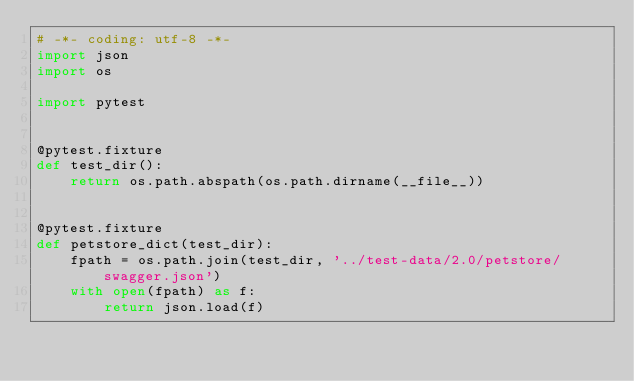Convert code to text. <code><loc_0><loc_0><loc_500><loc_500><_Python_># -*- coding: utf-8 -*-
import json
import os

import pytest


@pytest.fixture
def test_dir():
    return os.path.abspath(os.path.dirname(__file__))


@pytest.fixture
def petstore_dict(test_dir):
    fpath = os.path.join(test_dir, '../test-data/2.0/petstore/swagger.json')
    with open(fpath) as f:
        return json.load(f)
</code> 